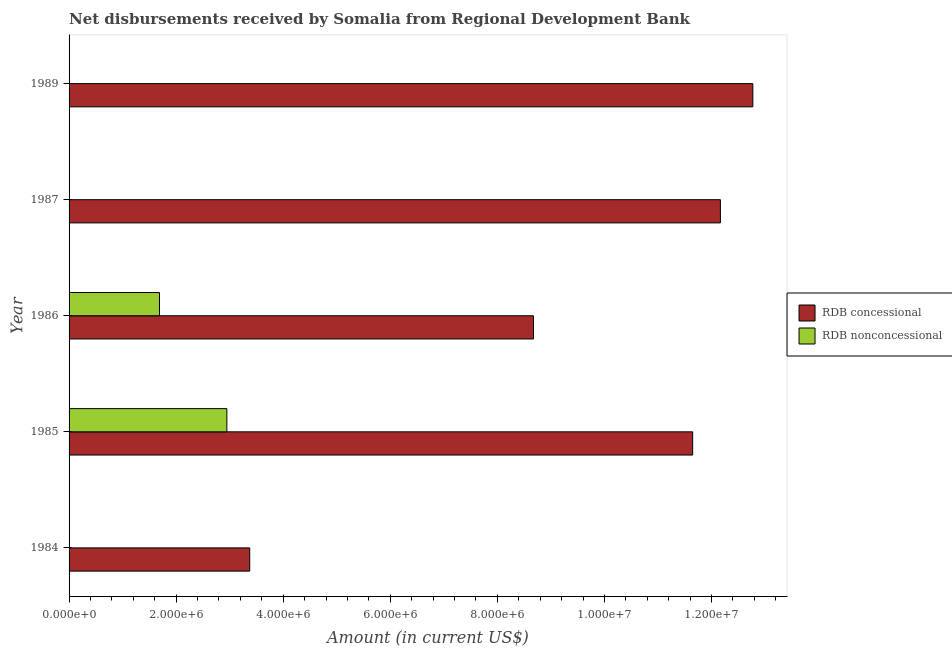How many different coloured bars are there?
Provide a short and direct response. 2. Are the number of bars per tick equal to the number of legend labels?
Keep it short and to the point. No. Are the number of bars on each tick of the Y-axis equal?
Offer a terse response. No. How many bars are there on the 5th tick from the bottom?
Make the answer very short. 1. What is the net non concessional disbursements from rdb in 1985?
Offer a terse response. 2.95e+06. Across all years, what is the maximum net non concessional disbursements from rdb?
Your answer should be very brief. 2.95e+06. Across all years, what is the minimum net concessional disbursements from rdb?
Offer a terse response. 3.37e+06. What is the total net concessional disbursements from rdb in the graph?
Offer a very short reply. 4.86e+07. What is the difference between the net concessional disbursements from rdb in 1984 and that in 1986?
Your response must be concise. -5.30e+06. What is the difference between the net concessional disbursements from rdb in 1987 and the net non concessional disbursements from rdb in 1985?
Keep it short and to the point. 9.22e+06. What is the average net non concessional disbursements from rdb per year?
Give a very brief answer. 9.27e+05. In the year 1985, what is the difference between the net non concessional disbursements from rdb and net concessional disbursements from rdb?
Give a very brief answer. -8.70e+06. What is the ratio of the net concessional disbursements from rdb in 1987 to that in 1989?
Offer a very short reply. 0.95. Is the net concessional disbursements from rdb in 1985 less than that in 1986?
Your answer should be compact. No. What is the difference between the highest and the second highest net concessional disbursements from rdb?
Give a very brief answer. 6.06e+05. What is the difference between the highest and the lowest net non concessional disbursements from rdb?
Keep it short and to the point. 2.95e+06. How many bars are there?
Make the answer very short. 7. How many years are there in the graph?
Your answer should be compact. 5. Are the values on the major ticks of X-axis written in scientific E-notation?
Offer a very short reply. Yes. How are the legend labels stacked?
Keep it short and to the point. Vertical. What is the title of the graph?
Give a very brief answer. Net disbursements received by Somalia from Regional Development Bank. Does "All education staff compensation" appear as one of the legend labels in the graph?
Provide a short and direct response. No. What is the label or title of the X-axis?
Your answer should be compact. Amount (in current US$). What is the label or title of the Y-axis?
Make the answer very short. Year. What is the Amount (in current US$) in RDB concessional in 1984?
Ensure brevity in your answer.  3.37e+06. What is the Amount (in current US$) of RDB concessional in 1985?
Make the answer very short. 1.16e+07. What is the Amount (in current US$) in RDB nonconcessional in 1985?
Offer a terse response. 2.95e+06. What is the Amount (in current US$) of RDB concessional in 1986?
Give a very brief answer. 8.67e+06. What is the Amount (in current US$) in RDB nonconcessional in 1986?
Offer a terse response. 1.69e+06. What is the Amount (in current US$) in RDB concessional in 1987?
Provide a succinct answer. 1.22e+07. What is the Amount (in current US$) of RDB concessional in 1989?
Keep it short and to the point. 1.28e+07. What is the Amount (in current US$) of RDB nonconcessional in 1989?
Offer a terse response. 0. Across all years, what is the maximum Amount (in current US$) of RDB concessional?
Give a very brief answer. 1.28e+07. Across all years, what is the maximum Amount (in current US$) in RDB nonconcessional?
Provide a succinct answer. 2.95e+06. Across all years, what is the minimum Amount (in current US$) of RDB concessional?
Your answer should be very brief. 3.37e+06. What is the total Amount (in current US$) of RDB concessional in the graph?
Offer a very short reply. 4.86e+07. What is the total Amount (in current US$) of RDB nonconcessional in the graph?
Provide a succinct answer. 4.64e+06. What is the difference between the Amount (in current US$) in RDB concessional in 1984 and that in 1985?
Provide a succinct answer. -8.27e+06. What is the difference between the Amount (in current US$) of RDB concessional in 1984 and that in 1986?
Your answer should be very brief. -5.30e+06. What is the difference between the Amount (in current US$) in RDB concessional in 1984 and that in 1987?
Provide a succinct answer. -8.79e+06. What is the difference between the Amount (in current US$) of RDB concessional in 1984 and that in 1989?
Your answer should be compact. -9.40e+06. What is the difference between the Amount (in current US$) in RDB concessional in 1985 and that in 1986?
Offer a terse response. 2.97e+06. What is the difference between the Amount (in current US$) in RDB nonconcessional in 1985 and that in 1986?
Provide a short and direct response. 1.26e+06. What is the difference between the Amount (in current US$) in RDB concessional in 1985 and that in 1987?
Your answer should be very brief. -5.18e+05. What is the difference between the Amount (in current US$) in RDB concessional in 1985 and that in 1989?
Give a very brief answer. -1.12e+06. What is the difference between the Amount (in current US$) of RDB concessional in 1986 and that in 1987?
Provide a short and direct response. -3.49e+06. What is the difference between the Amount (in current US$) in RDB concessional in 1986 and that in 1989?
Give a very brief answer. -4.10e+06. What is the difference between the Amount (in current US$) of RDB concessional in 1987 and that in 1989?
Make the answer very short. -6.06e+05. What is the difference between the Amount (in current US$) of RDB concessional in 1984 and the Amount (in current US$) of RDB nonconcessional in 1985?
Your answer should be very brief. 4.27e+05. What is the difference between the Amount (in current US$) in RDB concessional in 1984 and the Amount (in current US$) in RDB nonconcessional in 1986?
Your response must be concise. 1.68e+06. What is the difference between the Amount (in current US$) in RDB concessional in 1985 and the Amount (in current US$) in RDB nonconcessional in 1986?
Offer a terse response. 9.96e+06. What is the average Amount (in current US$) in RDB concessional per year?
Offer a very short reply. 9.73e+06. What is the average Amount (in current US$) of RDB nonconcessional per year?
Your response must be concise. 9.27e+05. In the year 1985, what is the difference between the Amount (in current US$) of RDB concessional and Amount (in current US$) of RDB nonconcessional?
Provide a short and direct response. 8.70e+06. In the year 1986, what is the difference between the Amount (in current US$) of RDB concessional and Amount (in current US$) of RDB nonconcessional?
Provide a succinct answer. 6.98e+06. What is the ratio of the Amount (in current US$) of RDB concessional in 1984 to that in 1985?
Offer a terse response. 0.29. What is the ratio of the Amount (in current US$) of RDB concessional in 1984 to that in 1986?
Make the answer very short. 0.39. What is the ratio of the Amount (in current US$) of RDB concessional in 1984 to that in 1987?
Your answer should be compact. 0.28. What is the ratio of the Amount (in current US$) of RDB concessional in 1984 to that in 1989?
Keep it short and to the point. 0.26. What is the ratio of the Amount (in current US$) of RDB concessional in 1985 to that in 1986?
Ensure brevity in your answer.  1.34. What is the ratio of the Amount (in current US$) of RDB nonconcessional in 1985 to that in 1986?
Provide a short and direct response. 1.74. What is the ratio of the Amount (in current US$) in RDB concessional in 1985 to that in 1987?
Give a very brief answer. 0.96. What is the ratio of the Amount (in current US$) of RDB concessional in 1985 to that in 1989?
Your answer should be very brief. 0.91. What is the ratio of the Amount (in current US$) of RDB concessional in 1986 to that in 1987?
Provide a succinct answer. 0.71. What is the ratio of the Amount (in current US$) in RDB concessional in 1986 to that in 1989?
Your response must be concise. 0.68. What is the ratio of the Amount (in current US$) in RDB concessional in 1987 to that in 1989?
Your answer should be very brief. 0.95. What is the difference between the highest and the second highest Amount (in current US$) in RDB concessional?
Provide a succinct answer. 6.06e+05. What is the difference between the highest and the lowest Amount (in current US$) of RDB concessional?
Your answer should be compact. 9.40e+06. What is the difference between the highest and the lowest Amount (in current US$) of RDB nonconcessional?
Your answer should be very brief. 2.95e+06. 